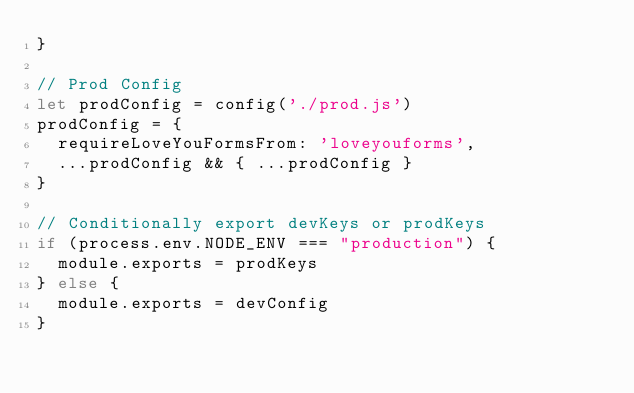Convert code to text. <code><loc_0><loc_0><loc_500><loc_500><_JavaScript_>}

// Prod Config
let prodConfig = config('./prod.js')
prodConfig = {
  requireLoveYouFormsFrom: 'loveyouforms',
  ...prodConfig && { ...prodConfig }
}

// Conditionally export devKeys or prodKeys
if (process.env.NODE_ENV === "production") {
  module.exports = prodKeys
} else {
  module.exports = devConfig
}
</code> 